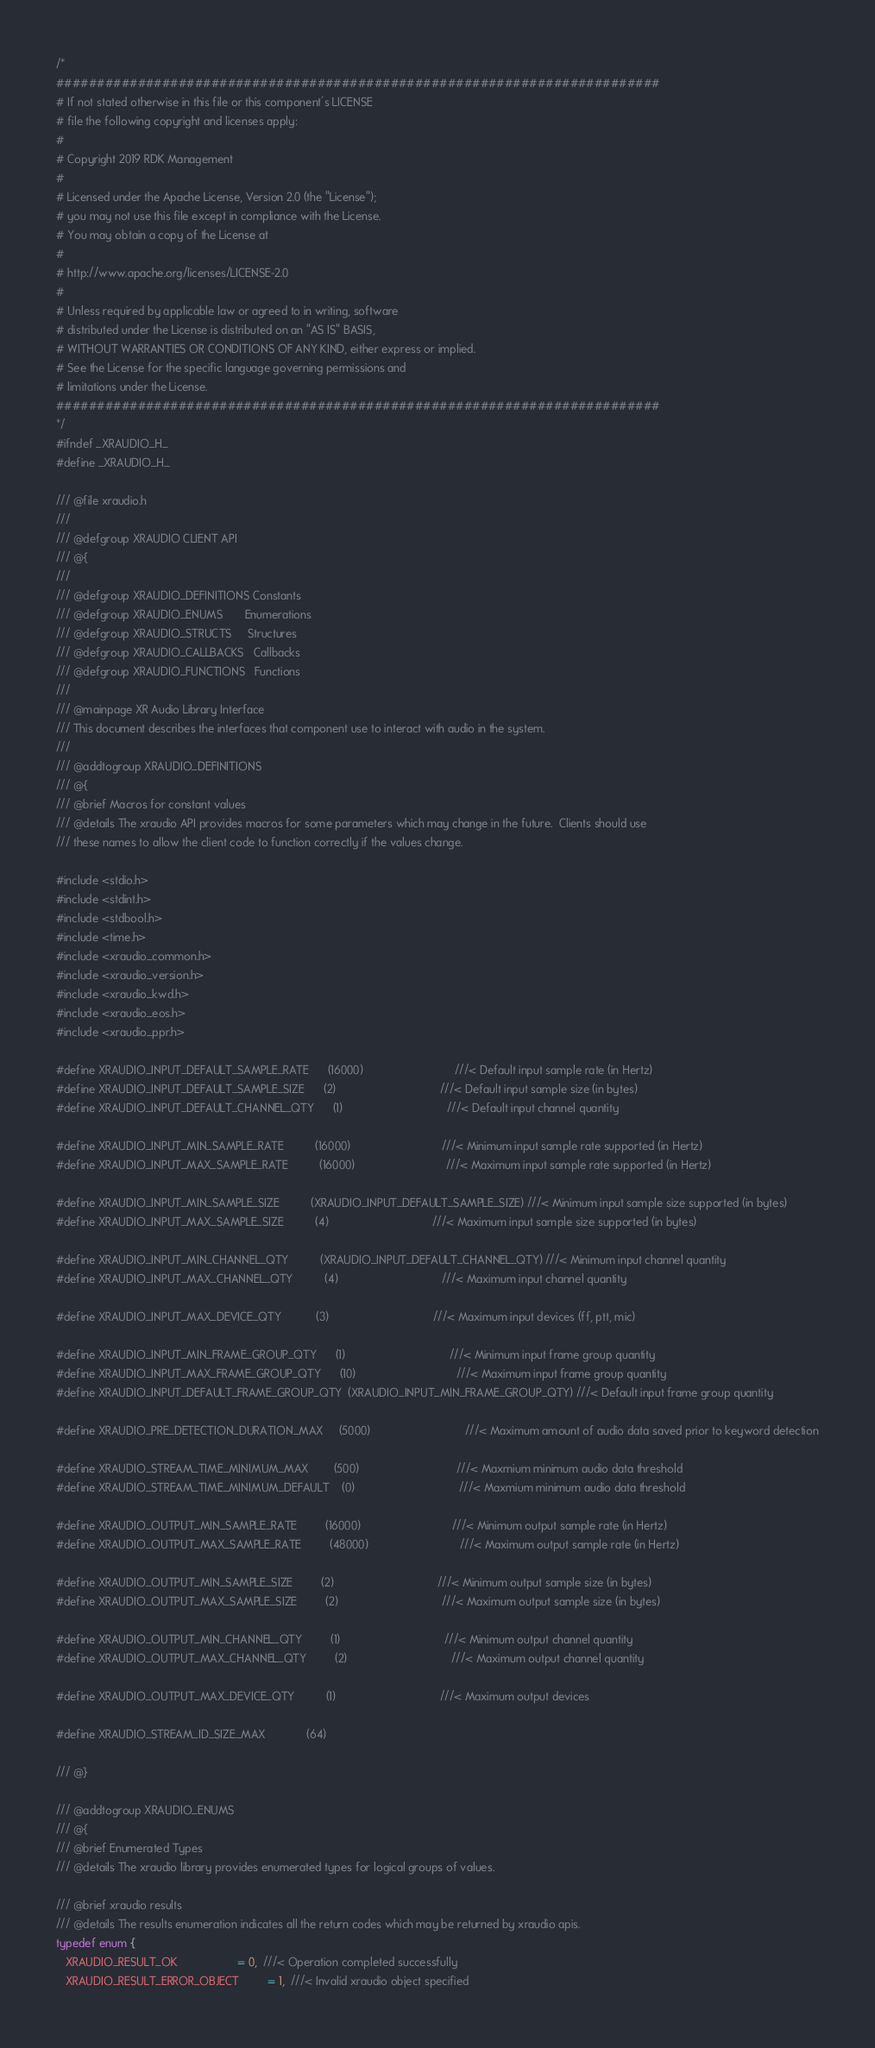<code> <loc_0><loc_0><loc_500><loc_500><_C_>/*
##########################################################################
# If not stated otherwise in this file or this component's LICENSE
# file the following copyright and licenses apply:
#
# Copyright 2019 RDK Management
#
# Licensed under the Apache License, Version 2.0 (the "License");
# you may not use this file except in compliance with the License.
# You may obtain a copy of the License at
#
# http://www.apache.org/licenses/LICENSE-2.0
#
# Unless required by applicable law or agreed to in writing, software
# distributed under the License is distributed on an "AS IS" BASIS,
# WITHOUT WARRANTIES OR CONDITIONS OF ANY KIND, either express or implied.
# See the License for the specific language governing permissions and
# limitations under the License.
##########################################################################
*/
#ifndef _XRAUDIO_H_
#define _XRAUDIO_H_

/// @file xraudio.h
///
/// @defgroup XRAUDIO CLIENT API
/// @{
///
/// @defgroup XRAUDIO_DEFINITIONS Constants
/// @defgroup XRAUDIO_ENUMS       Enumerations
/// @defgroup XRAUDIO_STRUCTS     Structures
/// @defgroup XRAUDIO_CALLBACKS   Callbacks
/// @defgroup XRAUDIO_FUNCTIONS   Functions
///
/// @mainpage XR Audio Library Interface
/// This document describes the interfaces that component use to interact with audio in the system.
///
/// @addtogroup XRAUDIO_DEFINITIONS
/// @{
/// @brief Macros for constant values
/// @details The xraudio API provides macros for some parameters which may change in the future.  Clients should use
/// these names to allow the client code to function correctly if the values change.

#include <stdio.h>
#include <stdint.h>
#include <stdbool.h>
#include <time.h>
#include <xraudio_common.h>
#include <xraudio_version.h>
#include <xraudio_kwd.h>
#include <xraudio_eos.h>
#include <xraudio_ppr.h>

#define XRAUDIO_INPUT_DEFAULT_SAMPLE_RATE      (16000)                             ///< Default input sample rate (in Hertz)
#define XRAUDIO_INPUT_DEFAULT_SAMPLE_SIZE      (2)                                 ///< Default input sample size (in bytes)
#define XRAUDIO_INPUT_DEFAULT_CHANNEL_QTY      (1)                                 ///< Default input channel quantity

#define XRAUDIO_INPUT_MIN_SAMPLE_RATE          (16000)                             ///< Minimum input sample rate supported (in Hertz)
#define XRAUDIO_INPUT_MAX_SAMPLE_RATE          (16000)                             ///< Maximum input sample rate supported (in Hertz)

#define XRAUDIO_INPUT_MIN_SAMPLE_SIZE          (XRAUDIO_INPUT_DEFAULT_SAMPLE_SIZE) ///< Minimum input sample size supported (in bytes)
#define XRAUDIO_INPUT_MAX_SAMPLE_SIZE          (4)                                 ///< Maximum input sample size supported (in bytes)

#define XRAUDIO_INPUT_MIN_CHANNEL_QTY          (XRAUDIO_INPUT_DEFAULT_CHANNEL_QTY) ///< Minimum input channel quantity
#define XRAUDIO_INPUT_MAX_CHANNEL_QTY          (4)                                 ///< Maximum input channel quantity

#define XRAUDIO_INPUT_MAX_DEVICE_QTY           (3)                                 ///< Maximum input devices (ff, ptt, mic)

#define XRAUDIO_INPUT_MIN_FRAME_GROUP_QTY      (1)                                 ///< Minimum input frame group quantity
#define XRAUDIO_INPUT_MAX_FRAME_GROUP_QTY      (10)                                ///< Maximum input frame group quantity
#define XRAUDIO_INPUT_DEFAULT_FRAME_GROUP_QTY  (XRAUDIO_INPUT_MIN_FRAME_GROUP_QTY) ///< Default input frame group quantity

#define XRAUDIO_PRE_DETECTION_DURATION_MAX     (5000)                              ///< Maximum amount of audio data saved prior to keyword detection

#define XRAUDIO_STREAM_TIME_MINIMUM_MAX        (500)                               ///< Maxmium minimum audio data threshold
#define XRAUDIO_STREAM_TIME_MINIMUM_DEFAULT    (0)                                 ///< Maxmium minimum audio data threshold

#define XRAUDIO_OUTPUT_MIN_SAMPLE_RATE         (16000)                             ///< Minimum output sample rate (in Hertz)
#define XRAUDIO_OUTPUT_MAX_SAMPLE_RATE         (48000)                             ///< Maximum output sample rate (in Hertz)

#define XRAUDIO_OUTPUT_MIN_SAMPLE_SIZE         (2)                                 ///< Minimum output sample size (in bytes)
#define XRAUDIO_OUTPUT_MAX_SAMPLE_SIZE         (2)                                 ///< Maximum output sample size (in bytes)

#define XRAUDIO_OUTPUT_MIN_CHANNEL_QTY         (1)                                 ///< Minimum output channel quantity
#define XRAUDIO_OUTPUT_MAX_CHANNEL_QTY         (2)                                 ///< Maximum output channel quantity

#define XRAUDIO_OUTPUT_MAX_DEVICE_QTY          (1)                                 ///< Maximum output devices

#define XRAUDIO_STREAM_ID_SIZE_MAX             (64)

/// @}

/// @addtogroup XRAUDIO_ENUMS
/// @{
/// @brief Enumerated Types
/// @details The xraudio library provides enumerated types for logical groups of values.

/// @brief xraudio results
/// @details The results enumeration indicates all the return codes which may be returned by xraudio apis.
typedef enum {
   XRAUDIO_RESULT_OK                   = 0,  ///< Operation completed successfully
   XRAUDIO_RESULT_ERROR_OBJECT         = 1,  ///< Invalid xraudio object specified</code> 